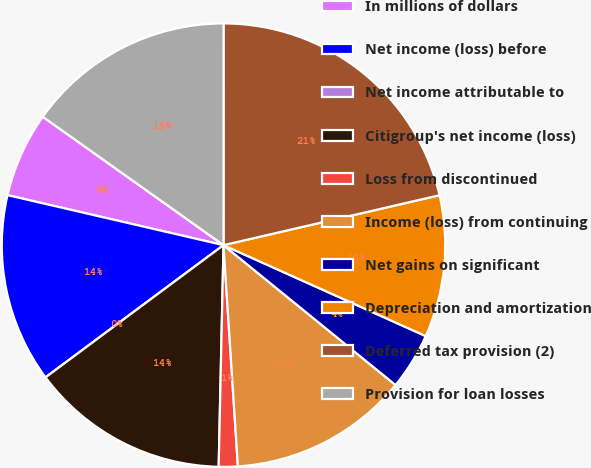<chart> <loc_0><loc_0><loc_500><loc_500><pie_chart><fcel>In millions of dollars<fcel>Net income (loss) before<fcel>Net income attributable to<fcel>Citigroup's net income (loss)<fcel>Loss from discontinued<fcel>Income (loss) from continuing<fcel>Net gains on significant<fcel>Depreciation and amortization<fcel>Deferred tax provision (2)<fcel>Provision for loan losses<nl><fcel>6.21%<fcel>13.79%<fcel>0.0%<fcel>14.48%<fcel>1.38%<fcel>13.1%<fcel>4.14%<fcel>10.34%<fcel>21.38%<fcel>15.17%<nl></chart> 